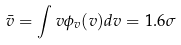Convert formula to latex. <formula><loc_0><loc_0><loc_500><loc_500>\bar { v } = \int v \phi _ { v } ( v ) d v = 1 . 6 \sigma</formula> 